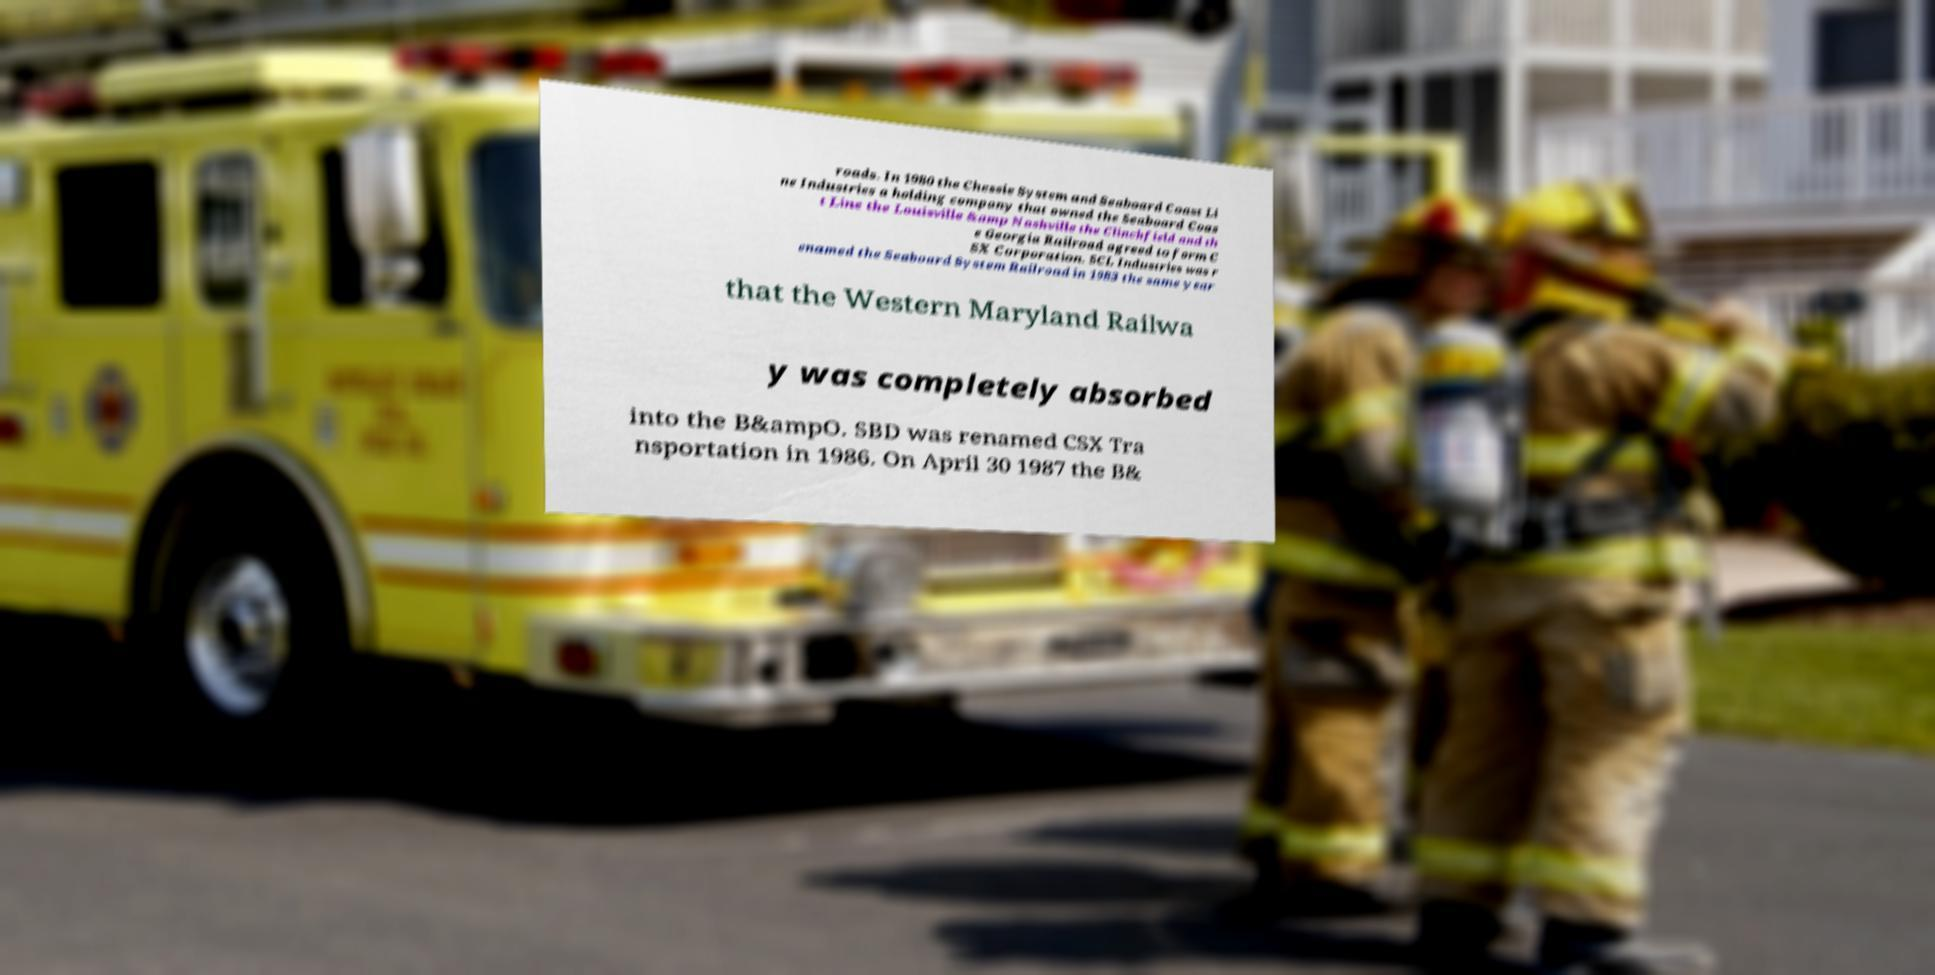What messages or text are displayed in this image? I need them in a readable, typed format. roads. In 1980 the Chessie System and Seaboard Coast Li ne Industries a holding company that owned the Seaboard Coas t Line the Louisville &amp Nashville the Clinchfield and th e Georgia Railroad agreed to form C SX Corporation. SCL Industries was r enamed the Seaboard System Railroad in 1983 the same year that the Western Maryland Railwa y was completely absorbed into the B&ampO. SBD was renamed CSX Tra nsportation in 1986. On April 30 1987 the B& 